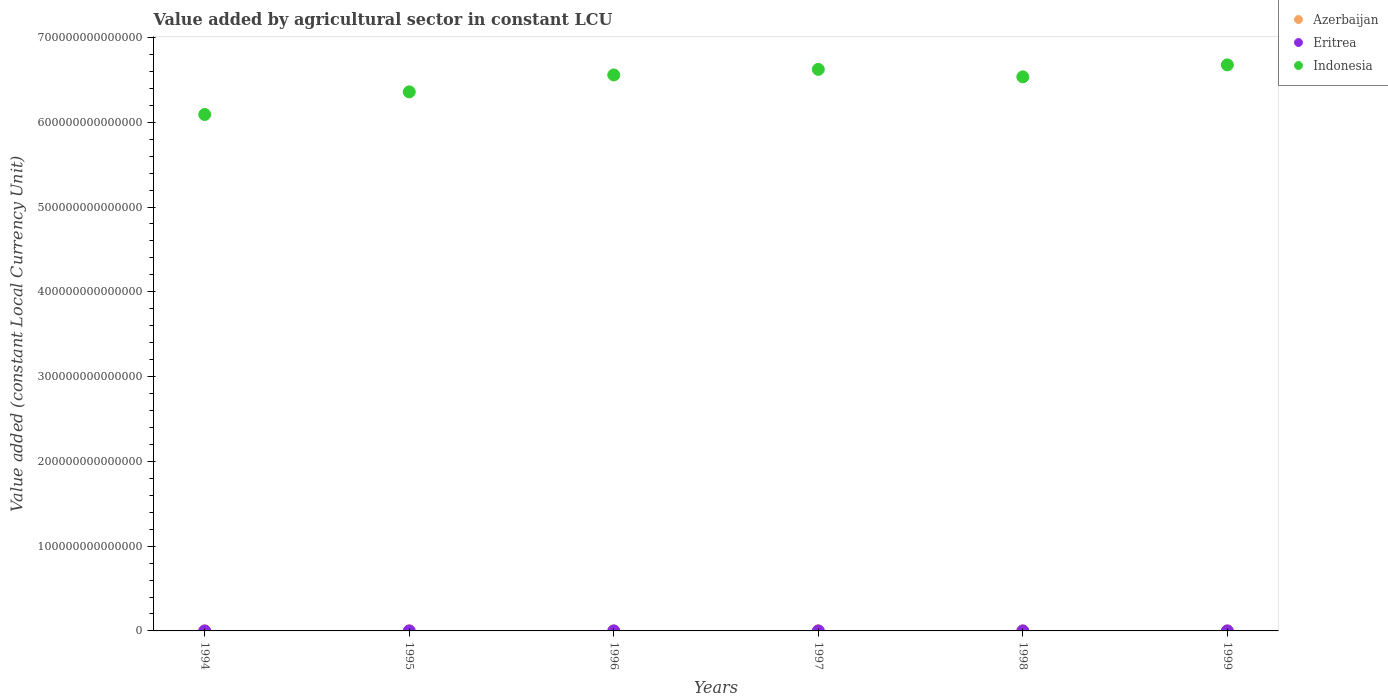How many different coloured dotlines are there?
Your response must be concise. 3. What is the value added by agricultural sector in Eritrea in 1995?
Keep it short and to the point. 1.10e+09. Across all years, what is the maximum value added by agricultural sector in Indonesia?
Your answer should be very brief. 6.68e+14. Across all years, what is the minimum value added by agricultural sector in Indonesia?
Ensure brevity in your answer.  6.09e+14. In which year was the value added by agricultural sector in Indonesia maximum?
Give a very brief answer. 1999. What is the total value added by agricultural sector in Azerbaijan in the graph?
Your answer should be very brief. 3.59e+09. What is the difference between the value added by agricultural sector in Azerbaijan in 1995 and that in 1998?
Keep it short and to the point. -1.07e+07. What is the difference between the value added by agricultural sector in Eritrea in 1994 and the value added by agricultural sector in Azerbaijan in 1999?
Ensure brevity in your answer.  6.12e+08. What is the average value added by agricultural sector in Azerbaijan per year?
Your answer should be compact. 5.99e+08. In the year 1998, what is the difference between the value added by agricultural sector in Eritrea and value added by agricultural sector in Indonesia?
Provide a short and direct response. -6.54e+14. What is the ratio of the value added by agricultural sector in Eritrea in 1994 to that in 1997?
Provide a succinct answer. 1.2. Is the value added by agricultural sector in Eritrea in 1994 less than that in 1996?
Your answer should be compact. No. What is the difference between the highest and the second highest value added by agricultural sector in Eritrea?
Offer a very short reply. 1.26e+08. What is the difference between the highest and the lowest value added by agricultural sector in Eritrea?
Your answer should be very brief. 6.03e+08. In how many years, is the value added by agricultural sector in Azerbaijan greater than the average value added by agricultural sector in Azerbaijan taken over all years?
Provide a succinct answer. 3. Is the value added by agricultural sector in Azerbaijan strictly greater than the value added by agricultural sector in Indonesia over the years?
Offer a very short reply. No. How many dotlines are there?
Your answer should be compact. 3. How many years are there in the graph?
Your answer should be compact. 6. What is the difference between two consecutive major ticks on the Y-axis?
Your response must be concise. 1.00e+14. Are the values on the major ticks of Y-axis written in scientific E-notation?
Provide a succinct answer. No. Does the graph contain any zero values?
Offer a very short reply. No. Does the graph contain grids?
Keep it short and to the point. No. How are the legend labels stacked?
Offer a terse response. Vertical. What is the title of the graph?
Your answer should be compact. Value added by agricultural sector in constant LCU. What is the label or title of the Y-axis?
Offer a very short reply. Value added (constant Local Currency Unit). What is the Value added (constant Local Currency Unit) of Azerbaijan in 1994?
Provide a succinct answer. 6.26e+08. What is the Value added (constant Local Currency Unit) of Eritrea in 1994?
Keep it short and to the point. 1.25e+09. What is the Value added (constant Local Currency Unit) of Indonesia in 1994?
Give a very brief answer. 6.09e+14. What is the Value added (constant Local Currency Unit) in Azerbaijan in 1995?
Offer a very short reply. 5.82e+08. What is the Value added (constant Local Currency Unit) in Eritrea in 1995?
Provide a succinct answer. 1.10e+09. What is the Value added (constant Local Currency Unit) of Indonesia in 1995?
Ensure brevity in your answer.  6.36e+14. What is the Value added (constant Local Currency Unit) of Azerbaijan in 1996?
Your answer should be compact. 5.99e+08. What is the Value added (constant Local Currency Unit) of Eritrea in 1996?
Offer a very short reply. 1.04e+09. What is the Value added (constant Local Currency Unit) in Indonesia in 1996?
Keep it short and to the point. 6.56e+14. What is the Value added (constant Local Currency Unit) of Azerbaijan in 1997?
Provide a succinct answer. 5.58e+08. What is the Value added (constant Local Currency Unit) of Eritrea in 1997?
Your answer should be very brief. 1.04e+09. What is the Value added (constant Local Currency Unit) of Indonesia in 1997?
Your answer should be compact. 6.62e+14. What is the Value added (constant Local Currency Unit) in Azerbaijan in 1998?
Your answer should be compact. 5.93e+08. What is the Value added (constant Local Currency Unit) of Eritrea in 1998?
Offer a very short reply. 1.64e+09. What is the Value added (constant Local Currency Unit) in Indonesia in 1998?
Give a very brief answer. 6.54e+14. What is the Value added (constant Local Currency Unit) in Azerbaijan in 1999?
Your response must be concise. 6.35e+08. What is the Value added (constant Local Currency Unit) of Eritrea in 1999?
Make the answer very short. 1.51e+09. What is the Value added (constant Local Currency Unit) of Indonesia in 1999?
Give a very brief answer. 6.68e+14. Across all years, what is the maximum Value added (constant Local Currency Unit) of Azerbaijan?
Your response must be concise. 6.35e+08. Across all years, what is the maximum Value added (constant Local Currency Unit) in Eritrea?
Give a very brief answer. 1.64e+09. Across all years, what is the maximum Value added (constant Local Currency Unit) of Indonesia?
Your answer should be very brief. 6.68e+14. Across all years, what is the minimum Value added (constant Local Currency Unit) of Azerbaijan?
Your answer should be very brief. 5.58e+08. Across all years, what is the minimum Value added (constant Local Currency Unit) in Eritrea?
Your answer should be compact. 1.04e+09. Across all years, what is the minimum Value added (constant Local Currency Unit) in Indonesia?
Provide a short and direct response. 6.09e+14. What is the total Value added (constant Local Currency Unit) in Azerbaijan in the graph?
Give a very brief answer. 3.59e+09. What is the total Value added (constant Local Currency Unit) in Eritrea in the graph?
Make the answer very short. 7.58e+09. What is the total Value added (constant Local Currency Unit) in Indonesia in the graph?
Your answer should be very brief. 3.88e+15. What is the difference between the Value added (constant Local Currency Unit) in Azerbaijan in 1994 and that in 1995?
Your answer should be very brief. 4.38e+07. What is the difference between the Value added (constant Local Currency Unit) of Eritrea in 1994 and that in 1995?
Keep it short and to the point. 1.46e+08. What is the difference between the Value added (constant Local Currency Unit) in Indonesia in 1994 and that in 1995?
Provide a succinct answer. -2.67e+13. What is the difference between the Value added (constant Local Currency Unit) of Azerbaijan in 1994 and that in 1996?
Provide a succinct answer. 2.63e+07. What is the difference between the Value added (constant Local Currency Unit) of Eritrea in 1994 and that in 1996?
Your answer should be compact. 2.09e+08. What is the difference between the Value added (constant Local Currency Unit) in Indonesia in 1994 and that in 1996?
Make the answer very short. -4.66e+13. What is the difference between the Value added (constant Local Currency Unit) in Azerbaijan in 1994 and that in 1997?
Ensure brevity in your answer.  6.77e+07. What is the difference between the Value added (constant Local Currency Unit) of Eritrea in 1994 and that in 1997?
Offer a terse response. 2.04e+08. What is the difference between the Value added (constant Local Currency Unit) in Indonesia in 1994 and that in 1997?
Your response must be concise. -5.32e+13. What is the difference between the Value added (constant Local Currency Unit) of Azerbaijan in 1994 and that in 1998?
Provide a succinct answer. 3.31e+07. What is the difference between the Value added (constant Local Currency Unit) of Eritrea in 1994 and that in 1998?
Provide a succinct answer. -3.94e+08. What is the difference between the Value added (constant Local Currency Unit) of Indonesia in 1994 and that in 1998?
Make the answer very short. -4.44e+13. What is the difference between the Value added (constant Local Currency Unit) in Azerbaijan in 1994 and that in 1999?
Make the answer very short. -8.97e+06. What is the difference between the Value added (constant Local Currency Unit) in Eritrea in 1994 and that in 1999?
Make the answer very short. -2.68e+08. What is the difference between the Value added (constant Local Currency Unit) in Indonesia in 1994 and that in 1999?
Keep it short and to the point. -5.85e+13. What is the difference between the Value added (constant Local Currency Unit) in Azerbaijan in 1995 and that in 1996?
Offer a terse response. -1.75e+07. What is the difference between the Value added (constant Local Currency Unit) of Eritrea in 1995 and that in 1996?
Your response must be concise. 6.34e+07. What is the difference between the Value added (constant Local Currency Unit) of Indonesia in 1995 and that in 1996?
Ensure brevity in your answer.  -2.00e+13. What is the difference between the Value added (constant Local Currency Unit) of Azerbaijan in 1995 and that in 1997?
Provide a short and direct response. 2.39e+07. What is the difference between the Value added (constant Local Currency Unit) in Eritrea in 1995 and that in 1997?
Give a very brief answer. 5.81e+07. What is the difference between the Value added (constant Local Currency Unit) in Indonesia in 1995 and that in 1997?
Provide a succinct answer. -2.65e+13. What is the difference between the Value added (constant Local Currency Unit) in Azerbaijan in 1995 and that in 1998?
Make the answer very short. -1.07e+07. What is the difference between the Value added (constant Local Currency Unit) of Eritrea in 1995 and that in 1998?
Your response must be concise. -5.40e+08. What is the difference between the Value added (constant Local Currency Unit) of Indonesia in 1995 and that in 1998?
Provide a short and direct response. -1.77e+13. What is the difference between the Value added (constant Local Currency Unit) of Azerbaijan in 1995 and that in 1999?
Provide a short and direct response. -5.28e+07. What is the difference between the Value added (constant Local Currency Unit) of Eritrea in 1995 and that in 1999?
Provide a short and direct response. -4.14e+08. What is the difference between the Value added (constant Local Currency Unit) in Indonesia in 1995 and that in 1999?
Keep it short and to the point. -3.19e+13. What is the difference between the Value added (constant Local Currency Unit) of Azerbaijan in 1996 and that in 1997?
Your answer should be compact. 4.14e+07. What is the difference between the Value added (constant Local Currency Unit) in Eritrea in 1996 and that in 1997?
Make the answer very short. -5.30e+06. What is the difference between the Value added (constant Local Currency Unit) of Indonesia in 1996 and that in 1997?
Your response must be concise. -6.58e+12. What is the difference between the Value added (constant Local Currency Unit) in Azerbaijan in 1996 and that in 1998?
Ensure brevity in your answer.  6.76e+06. What is the difference between the Value added (constant Local Currency Unit) in Eritrea in 1996 and that in 1998?
Your answer should be compact. -6.03e+08. What is the difference between the Value added (constant Local Currency Unit) in Indonesia in 1996 and that in 1998?
Make the answer very short. 2.24e+12. What is the difference between the Value added (constant Local Currency Unit) of Azerbaijan in 1996 and that in 1999?
Your response must be concise. -3.53e+07. What is the difference between the Value added (constant Local Currency Unit) in Eritrea in 1996 and that in 1999?
Ensure brevity in your answer.  -4.78e+08. What is the difference between the Value added (constant Local Currency Unit) of Indonesia in 1996 and that in 1999?
Offer a very short reply. -1.19e+13. What is the difference between the Value added (constant Local Currency Unit) of Azerbaijan in 1997 and that in 1998?
Make the answer very short. -3.46e+07. What is the difference between the Value added (constant Local Currency Unit) of Eritrea in 1997 and that in 1998?
Provide a short and direct response. -5.98e+08. What is the difference between the Value added (constant Local Currency Unit) in Indonesia in 1997 and that in 1998?
Provide a short and direct response. 8.82e+12. What is the difference between the Value added (constant Local Currency Unit) of Azerbaijan in 1997 and that in 1999?
Provide a short and direct response. -7.67e+07. What is the difference between the Value added (constant Local Currency Unit) of Eritrea in 1997 and that in 1999?
Your response must be concise. -4.72e+08. What is the difference between the Value added (constant Local Currency Unit) in Indonesia in 1997 and that in 1999?
Ensure brevity in your answer.  -5.32e+12. What is the difference between the Value added (constant Local Currency Unit) in Azerbaijan in 1998 and that in 1999?
Provide a succinct answer. -4.21e+07. What is the difference between the Value added (constant Local Currency Unit) in Eritrea in 1998 and that in 1999?
Provide a short and direct response. 1.26e+08. What is the difference between the Value added (constant Local Currency Unit) of Indonesia in 1998 and that in 1999?
Make the answer very short. -1.41e+13. What is the difference between the Value added (constant Local Currency Unit) of Azerbaijan in 1994 and the Value added (constant Local Currency Unit) of Eritrea in 1995?
Provide a succinct answer. -4.75e+08. What is the difference between the Value added (constant Local Currency Unit) in Azerbaijan in 1994 and the Value added (constant Local Currency Unit) in Indonesia in 1995?
Make the answer very short. -6.36e+14. What is the difference between the Value added (constant Local Currency Unit) of Eritrea in 1994 and the Value added (constant Local Currency Unit) of Indonesia in 1995?
Offer a very short reply. -6.36e+14. What is the difference between the Value added (constant Local Currency Unit) in Azerbaijan in 1994 and the Value added (constant Local Currency Unit) in Eritrea in 1996?
Ensure brevity in your answer.  -4.12e+08. What is the difference between the Value added (constant Local Currency Unit) of Azerbaijan in 1994 and the Value added (constant Local Currency Unit) of Indonesia in 1996?
Keep it short and to the point. -6.56e+14. What is the difference between the Value added (constant Local Currency Unit) in Eritrea in 1994 and the Value added (constant Local Currency Unit) in Indonesia in 1996?
Give a very brief answer. -6.56e+14. What is the difference between the Value added (constant Local Currency Unit) of Azerbaijan in 1994 and the Value added (constant Local Currency Unit) of Eritrea in 1997?
Your answer should be very brief. -4.17e+08. What is the difference between the Value added (constant Local Currency Unit) in Azerbaijan in 1994 and the Value added (constant Local Currency Unit) in Indonesia in 1997?
Keep it short and to the point. -6.62e+14. What is the difference between the Value added (constant Local Currency Unit) of Eritrea in 1994 and the Value added (constant Local Currency Unit) of Indonesia in 1997?
Your answer should be very brief. -6.62e+14. What is the difference between the Value added (constant Local Currency Unit) in Azerbaijan in 1994 and the Value added (constant Local Currency Unit) in Eritrea in 1998?
Your response must be concise. -1.02e+09. What is the difference between the Value added (constant Local Currency Unit) of Azerbaijan in 1994 and the Value added (constant Local Currency Unit) of Indonesia in 1998?
Offer a very short reply. -6.54e+14. What is the difference between the Value added (constant Local Currency Unit) of Eritrea in 1994 and the Value added (constant Local Currency Unit) of Indonesia in 1998?
Keep it short and to the point. -6.54e+14. What is the difference between the Value added (constant Local Currency Unit) of Azerbaijan in 1994 and the Value added (constant Local Currency Unit) of Eritrea in 1999?
Your answer should be compact. -8.89e+08. What is the difference between the Value added (constant Local Currency Unit) in Azerbaijan in 1994 and the Value added (constant Local Currency Unit) in Indonesia in 1999?
Your answer should be very brief. -6.68e+14. What is the difference between the Value added (constant Local Currency Unit) of Eritrea in 1994 and the Value added (constant Local Currency Unit) of Indonesia in 1999?
Offer a terse response. -6.68e+14. What is the difference between the Value added (constant Local Currency Unit) of Azerbaijan in 1995 and the Value added (constant Local Currency Unit) of Eritrea in 1996?
Ensure brevity in your answer.  -4.56e+08. What is the difference between the Value added (constant Local Currency Unit) in Azerbaijan in 1995 and the Value added (constant Local Currency Unit) in Indonesia in 1996?
Offer a terse response. -6.56e+14. What is the difference between the Value added (constant Local Currency Unit) of Eritrea in 1995 and the Value added (constant Local Currency Unit) of Indonesia in 1996?
Your answer should be compact. -6.56e+14. What is the difference between the Value added (constant Local Currency Unit) in Azerbaijan in 1995 and the Value added (constant Local Currency Unit) in Eritrea in 1997?
Give a very brief answer. -4.61e+08. What is the difference between the Value added (constant Local Currency Unit) in Azerbaijan in 1995 and the Value added (constant Local Currency Unit) in Indonesia in 1997?
Offer a terse response. -6.62e+14. What is the difference between the Value added (constant Local Currency Unit) in Eritrea in 1995 and the Value added (constant Local Currency Unit) in Indonesia in 1997?
Your answer should be compact. -6.62e+14. What is the difference between the Value added (constant Local Currency Unit) of Azerbaijan in 1995 and the Value added (constant Local Currency Unit) of Eritrea in 1998?
Keep it short and to the point. -1.06e+09. What is the difference between the Value added (constant Local Currency Unit) of Azerbaijan in 1995 and the Value added (constant Local Currency Unit) of Indonesia in 1998?
Give a very brief answer. -6.54e+14. What is the difference between the Value added (constant Local Currency Unit) of Eritrea in 1995 and the Value added (constant Local Currency Unit) of Indonesia in 1998?
Offer a very short reply. -6.54e+14. What is the difference between the Value added (constant Local Currency Unit) of Azerbaijan in 1995 and the Value added (constant Local Currency Unit) of Eritrea in 1999?
Give a very brief answer. -9.33e+08. What is the difference between the Value added (constant Local Currency Unit) of Azerbaijan in 1995 and the Value added (constant Local Currency Unit) of Indonesia in 1999?
Offer a very short reply. -6.68e+14. What is the difference between the Value added (constant Local Currency Unit) in Eritrea in 1995 and the Value added (constant Local Currency Unit) in Indonesia in 1999?
Offer a very short reply. -6.68e+14. What is the difference between the Value added (constant Local Currency Unit) of Azerbaijan in 1996 and the Value added (constant Local Currency Unit) of Eritrea in 1997?
Keep it short and to the point. -4.43e+08. What is the difference between the Value added (constant Local Currency Unit) of Azerbaijan in 1996 and the Value added (constant Local Currency Unit) of Indonesia in 1997?
Make the answer very short. -6.62e+14. What is the difference between the Value added (constant Local Currency Unit) of Eritrea in 1996 and the Value added (constant Local Currency Unit) of Indonesia in 1997?
Give a very brief answer. -6.62e+14. What is the difference between the Value added (constant Local Currency Unit) of Azerbaijan in 1996 and the Value added (constant Local Currency Unit) of Eritrea in 1998?
Provide a short and direct response. -1.04e+09. What is the difference between the Value added (constant Local Currency Unit) in Azerbaijan in 1996 and the Value added (constant Local Currency Unit) in Indonesia in 1998?
Your response must be concise. -6.54e+14. What is the difference between the Value added (constant Local Currency Unit) of Eritrea in 1996 and the Value added (constant Local Currency Unit) of Indonesia in 1998?
Make the answer very short. -6.54e+14. What is the difference between the Value added (constant Local Currency Unit) of Azerbaijan in 1996 and the Value added (constant Local Currency Unit) of Eritrea in 1999?
Ensure brevity in your answer.  -9.16e+08. What is the difference between the Value added (constant Local Currency Unit) of Azerbaijan in 1996 and the Value added (constant Local Currency Unit) of Indonesia in 1999?
Your response must be concise. -6.68e+14. What is the difference between the Value added (constant Local Currency Unit) of Eritrea in 1996 and the Value added (constant Local Currency Unit) of Indonesia in 1999?
Ensure brevity in your answer.  -6.68e+14. What is the difference between the Value added (constant Local Currency Unit) in Azerbaijan in 1997 and the Value added (constant Local Currency Unit) in Eritrea in 1998?
Keep it short and to the point. -1.08e+09. What is the difference between the Value added (constant Local Currency Unit) of Azerbaijan in 1997 and the Value added (constant Local Currency Unit) of Indonesia in 1998?
Keep it short and to the point. -6.54e+14. What is the difference between the Value added (constant Local Currency Unit) of Eritrea in 1997 and the Value added (constant Local Currency Unit) of Indonesia in 1998?
Make the answer very short. -6.54e+14. What is the difference between the Value added (constant Local Currency Unit) in Azerbaijan in 1997 and the Value added (constant Local Currency Unit) in Eritrea in 1999?
Provide a succinct answer. -9.57e+08. What is the difference between the Value added (constant Local Currency Unit) in Azerbaijan in 1997 and the Value added (constant Local Currency Unit) in Indonesia in 1999?
Keep it short and to the point. -6.68e+14. What is the difference between the Value added (constant Local Currency Unit) in Eritrea in 1997 and the Value added (constant Local Currency Unit) in Indonesia in 1999?
Your answer should be compact. -6.68e+14. What is the difference between the Value added (constant Local Currency Unit) in Azerbaijan in 1998 and the Value added (constant Local Currency Unit) in Eritrea in 1999?
Offer a terse response. -9.22e+08. What is the difference between the Value added (constant Local Currency Unit) in Azerbaijan in 1998 and the Value added (constant Local Currency Unit) in Indonesia in 1999?
Give a very brief answer. -6.68e+14. What is the difference between the Value added (constant Local Currency Unit) in Eritrea in 1998 and the Value added (constant Local Currency Unit) in Indonesia in 1999?
Give a very brief answer. -6.68e+14. What is the average Value added (constant Local Currency Unit) in Azerbaijan per year?
Offer a terse response. 5.99e+08. What is the average Value added (constant Local Currency Unit) of Eritrea per year?
Your response must be concise. 1.26e+09. What is the average Value added (constant Local Currency Unit) of Indonesia per year?
Your response must be concise. 6.47e+14. In the year 1994, what is the difference between the Value added (constant Local Currency Unit) in Azerbaijan and Value added (constant Local Currency Unit) in Eritrea?
Make the answer very short. -6.21e+08. In the year 1994, what is the difference between the Value added (constant Local Currency Unit) of Azerbaijan and Value added (constant Local Currency Unit) of Indonesia?
Your answer should be compact. -6.09e+14. In the year 1994, what is the difference between the Value added (constant Local Currency Unit) in Eritrea and Value added (constant Local Currency Unit) in Indonesia?
Keep it short and to the point. -6.09e+14. In the year 1995, what is the difference between the Value added (constant Local Currency Unit) in Azerbaijan and Value added (constant Local Currency Unit) in Eritrea?
Offer a terse response. -5.19e+08. In the year 1995, what is the difference between the Value added (constant Local Currency Unit) in Azerbaijan and Value added (constant Local Currency Unit) in Indonesia?
Your answer should be compact. -6.36e+14. In the year 1995, what is the difference between the Value added (constant Local Currency Unit) of Eritrea and Value added (constant Local Currency Unit) of Indonesia?
Give a very brief answer. -6.36e+14. In the year 1996, what is the difference between the Value added (constant Local Currency Unit) of Azerbaijan and Value added (constant Local Currency Unit) of Eritrea?
Your answer should be very brief. -4.38e+08. In the year 1996, what is the difference between the Value added (constant Local Currency Unit) of Azerbaijan and Value added (constant Local Currency Unit) of Indonesia?
Your answer should be compact. -6.56e+14. In the year 1996, what is the difference between the Value added (constant Local Currency Unit) of Eritrea and Value added (constant Local Currency Unit) of Indonesia?
Your answer should be compact. -6.56e+14. In the year 1997, what is the difference between the Value added (constant Local Currency Unit) in Azerbaijan and Value added (constant Local Currency Unit) in Eritrea?
Your answer should be compact. -4.85e+08. In the year 1997, what is the difference between the Value added (constant Local Currency Unit) of Azerbaijan and Value added (constant Local Currency Unit) of Indonesia?
Make the answer very short. -6.62e+14. In the year 1997, what is the difference between the Value added (constant Local Currency Unit) of Eritrea and Value added (constant Local Currency Unit) of Indonesia?
Offer a very short reply. -6.62e+14. In the year 1998, what is the difference between the Value added (constant Local Currency Unit) in Azerbaijan and Value added (constant Local Currency Unit) in Eritrea?
Provide a succinct answer. -1.05e+09. In the year 1998, what is the difference between the Value added (constant Local Currency Unit) of Azerbaijan and Value added (constant Local Currency Unit) of Indonesia?
Provide a short and direct response. -6.54e+14. In the year 1998, what is the difference between the Value added (constant Local Currency Unit) in Eritrea and Value added (constant Local Currency Unit) in Indonesia?
Offer a very short reply. -6.54e+14. In the year 1999, what is the difference between the Value added (constant Local Currency Unit) in Azerbaijan and Value added (constant Local Currency Unit) in Eritrea?
Ensure brevity in your answer.  -8.80e+08. In the year 1999, what is the difference between the Value added (constant Local Currency Unit) of Azerbaijan and Value added (constant Local Currency Unit) of Indonesia?
Provide a succinct answer. -6.68e+14. In the year 1999, what is the difference between the Value added (constant Local Currency Unit) in Eritrea and Value added (constant Local Currency Unit) in Indonesia?
Keep it short and to the point. -6.68e+14. What is the ratio of the Value added (constant Local Currency Unit) of Azerbaijan in 1994 to that in 1995?
Provide a succinct answer. 1.08. What is the ratio of the Value added (constant Local Currency Unit) in Eritrea in 1994 to that in 1995?
Your response must be concise. 1.13. What is the ratio of the Value added (constant Local Currency Unit) of Indonesia in 1994 to that in 1995?
Ensure brevity in your answer.  0.96. What is the ratio of the Value added (constant Local Currency Unit) in Azerbaijan in 1994 to that in 1996?
Keep it short and to the point. 1.04. What is the ratio of the Value added (constant Local Currency Unit) of Eritrea in 1994 to that in 1996?
Your response must be concise. 1.2. What is the ratio of the Value added (constant Local Currency Unit) in Indonesia in 1994 to that in 1996?
Offer a very short reply. 0.93. What is the ratio of the Value added (constant Local Currency Unit) in Azerbaijan in 1994 to that in 1997?
Provide a short and direct response. 1.12. What is the ratio of the Value added (constant Local Currency Unit) in Eritrea in 1994 to that in 1997?
Your answer should be very brief. 1.2. What is the ratio of the Value added (constant Local Currency Unit) in Indonesia in 1994 to that in 1997?
Ensure brevity in your answer.  0.92. What is the ratio of the Value added (constant Local Currency Unit) of Azerbaijan in 1994 to that in 1998?
Offer a terse response. 1.06. What is the ratio of the Value added (constant Local Currency Unit) of Eritrea in 1994 to that in 1998?
Make the answer very short. 0.76. What is the ratio of the Value added (constant Local Currency Unit) in Indonesia in 1994 to that in 1998?
Provide a succinct answer. 0.93. What is the ratio of the Value added (constant Local Currency Unit) in Azerbaijan in 1994 to that in 1999?
Your answer should be very brief. 0.99. What is the ratio of the Value added (constant Local Currency Unit) of Eritrea in 1994 to that in 1999?
Keep it short and to the point. 0.82. What is the ratio of the Value added (constant Local Currency Unit) in Indonesia in 1994 to that in 1999?
Provide a succinct answer. 0.91. What is the ratio of the Value added (constant Local Currency Unit) of Azerbaijan in 1995 to that in 1996?
Your answer should be very brief. 0.97. What is the ratio of the Value added (constant Local Currency Unit) of Eritrea in 1995 to that in 1996?
Ensure brevity in your answer.  1.06. What is the ratio of the Value added (constant Local Currency Unit) of Indonesia in 1995 to that in 1996?
Ensure brevity in your answer.  0.97. What is the ratio of the Value added (constant Local Currency Unit) of Azerbaijan in 1995 to that in 1997?
Provide a short and direct response. 1.04. What is the ratio of the Value added (constant Local Currency Unit) of Eritrea in 1995 to that in 1997?
Give a very brief answer. 1.06. What is the ratio of the Value added (constant Local Currency Unit) in Indonesia in 1995 to that in 1997?
Your answer should be very brief. 0.96. What is the ratio of the Value added (constant Local Currency Unit) in Azerbaijan in 1995 to that in 1998?
Give a very brief answer. 0.98. What is the ratio of the Value added (constant Local Currency Unit) of Eritrea in 1995 to that in 1998?
Your answer should be very brief. 0.67. What is the ratio of the Value added (constant Local Currency Unit) in Indonesia in 1995 to that in 1998?
Keep it short and to the point. 0.97. What is the ratio of the Value added (constant Local Currency Unit) of Azerbaijan in 1995 to that in 1999?
Offer a very short reply. 0.92. What is the ratio of the Value added (constant Local Currency Unit) in Eritrea in 1995 to that in 1999?
Your response must be concise. 0.73. What is the ratio of the Value added (constant Local Currency Unit) in Indonesia in 1995 to that in 1999?
Provide a succinct answer. 0.95. What is the ratio of the Value added (constant Local Currency Unit) of Azerbaijan in 1996 to that in 1997?
Ensure brevity in your answer.  1.07. What is the ratio of the Value added (constant Local Currency Unit) of Azerbaijan in 1996 to that in 1998?
Your answer should be very brief. 1.01. What is the ratio of the Value added (constant Local Currency Unit) of Eritrea in 1996 to that in 1998?
Offer a terse response. 0.63. What is the ratio of the Value added (constant Local Currency Unit) in Indonesia in 1996 to that in 1998?
Provide a succinct answer. 1. What is the ratio of the Value added (constant Local Currency Unit) in Eritrea in 1996 to that in 1999?
Offer a terse response. 0.68. What is the ratio of the Value added (constant Local Currency Unit) of Indonesia in 1996 to that in 1999?
Keep it short and to the point. 0.98. What is the ratio of the Value added (constant Local Currency Unit) of Azerbaijan in 1997 to that in 1998?
Provide a short and direct response. 0.94. What is the ratio of the Value added (constant Local Currency Unit) of Eritrea in 1997 to that in 1998?
Your answer should be compact. 0.64. What is the ratio of the Value added (constant Local Currency Unit) in Indonesia in 1997 to that in 1998?
Your answer should be compact. 1.01. What is the ratio of the Value added (constant Local Currency Unit) in Azerbaijan in 1997 to that in 1999?
Your answer should be very brief. 0.88. What is the ratio of the Value added (constant Local Currency Unit) in Eritrea in 1997 to that in 1999?
Make the answer very short. 0.69. What is the ratio of the Value added (constant Local Currency Unit) of Azerbaijan in 1998 to that in 1999?
Ensure brevity in your answer.  0.93. What is the ratio of the Value added (constant Local Currency Unit) in Eritrea in 1998 to that in 1999?
Your response must be concise. 1.08. What is the ratio of the Value added (constant Local Currency Unit) in Indonesia in 1998 to that in 1999?
Ensure brevity in your answer.  0.98. What is the difference between the highest and the second highest Value added (constant Local Currency Unit) in Azerbaijan?
Offer a very short reply. 8.97e+06. What is the difference between the highest and the second highest Value added (constant Local Currency Unit) of Eritrea?
Offer a terse response. 1.26e+08. What is the difference between the highest and the second highest Value added (constant Local Currency Unit) of Indonesia?
Keep it short and to the point. 5.32e+12. What is the difference between the highest and the lowest Value added (constant Local Currency Unit) of Azerbaijan?
Make the answer very short. 7.67e+07. What is the difference between the highest and the lowest Value added (constant Local Currency Unit) in Eritrea?
Provide a succinct answer. 6.03e+08. What is the difference between the highest and the lowest Value added (constant Local Currency Unit) of Indonesia?
Offer a terse response. 5.85e+13. 